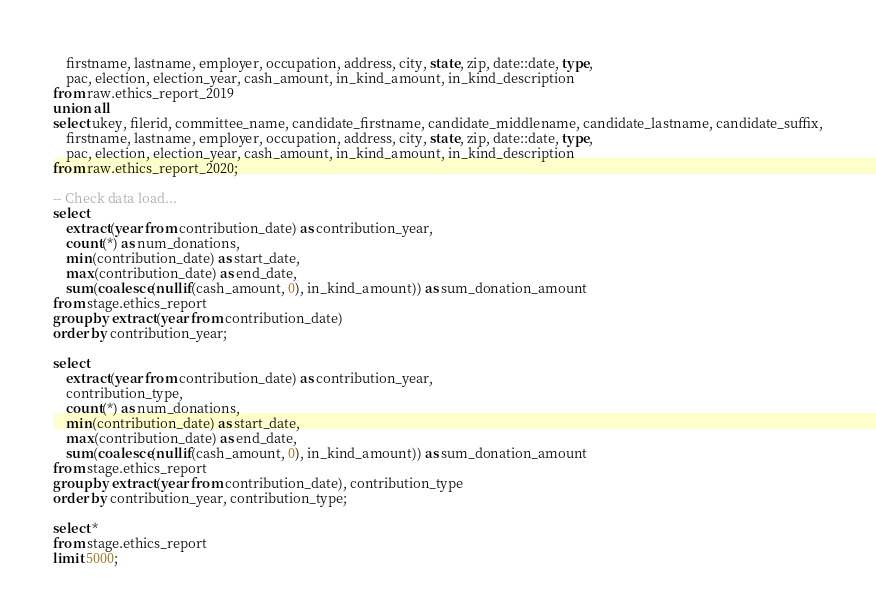Convert code to text. <code><loc_0><loc_0><loc_500><loc_500><_SQL_>    firstname, lastname, employer, occupation, address, city, state, zip, date::date, type,
    pac, election, election_year, cash_amount, in_kind_amount, in_kind_description
from raw.ethics_report_2019
union all
select ukey, filerid, committee_name, candidate_firstname, candidate_middlename, candidate_lastname, candidate_suffix,
    firstname, lastname, employer, occupation, address, city, state, zip, date::date, type,
    pac, election, election_year, cash_amount, in_kind_amount, in_kind_description
from raw.ethics_report_2020;

-- Check data load...
select
    extract(year from contribution_date) as contribution_year,
    count(*) as num_donations,
    min(contribution_date) as start_date,
    max(contribution_date) as end_date,
    sum(coalesce(nullif(cash_amount, 0), in_kind_amount)) as sum_donation_amount
from stage.ethics_report
group by extract(year from contribution_date)
order by contribution_year;

select
    extract(year from contribution_date) as contribution_year,
    contribution_type,
    count(*) as num_donations,
    min(contribution_date) as start_date,
    max(contribution_date) as end_date,
    sum(coalesce(nullif(cash_amount, 0), in_kind_amount)) as sum_donation_amount
from stage.ethics_report
group by extract(year from contribution_date), contribution_type
order by contribution_year, contribution_type;

select *
from stage.ethics_report
limit 5000;
</code> 